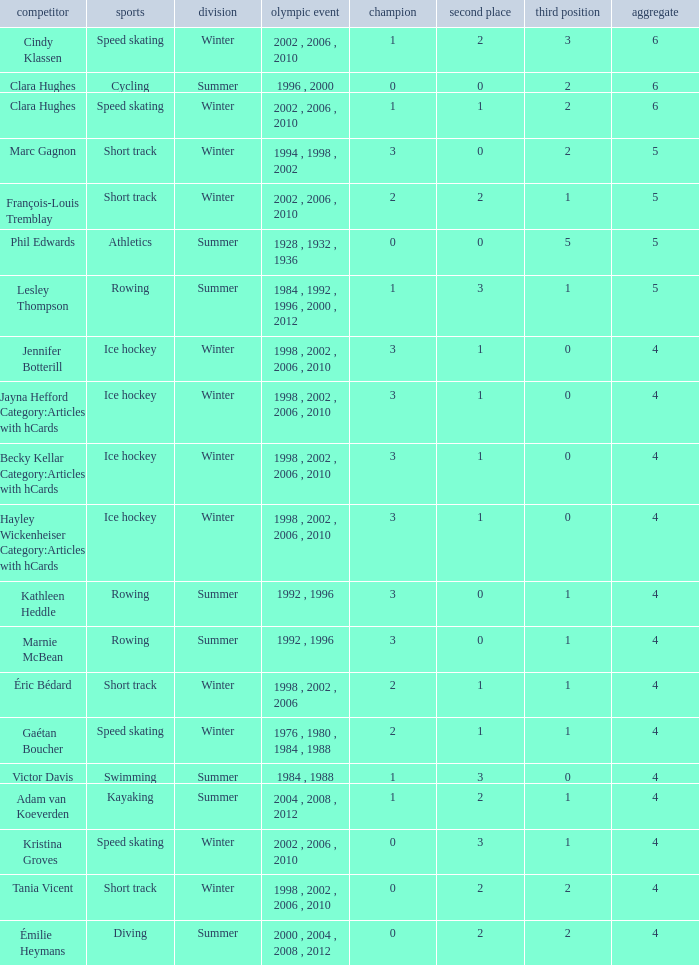What is the average gold of the winter athlete with 1 bronze, less than 3 silver, and less than 4 total medals? None. 